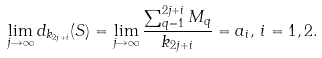Convert formula to latex. <formula><loc_0><loc_0><loc_500><loc_500>\lim _ { j \rightarrow \infty } d _ { k _ { 2 j + i } } ( S ) = \lim _ { j \rightarrow \infty } \frac { \sum _ { q = 1 } ^ { 2 j + i } M _ { q } } { k _ { 2 j + i } } = a _ { i } , \, i = 1 , 2 .</formula> 